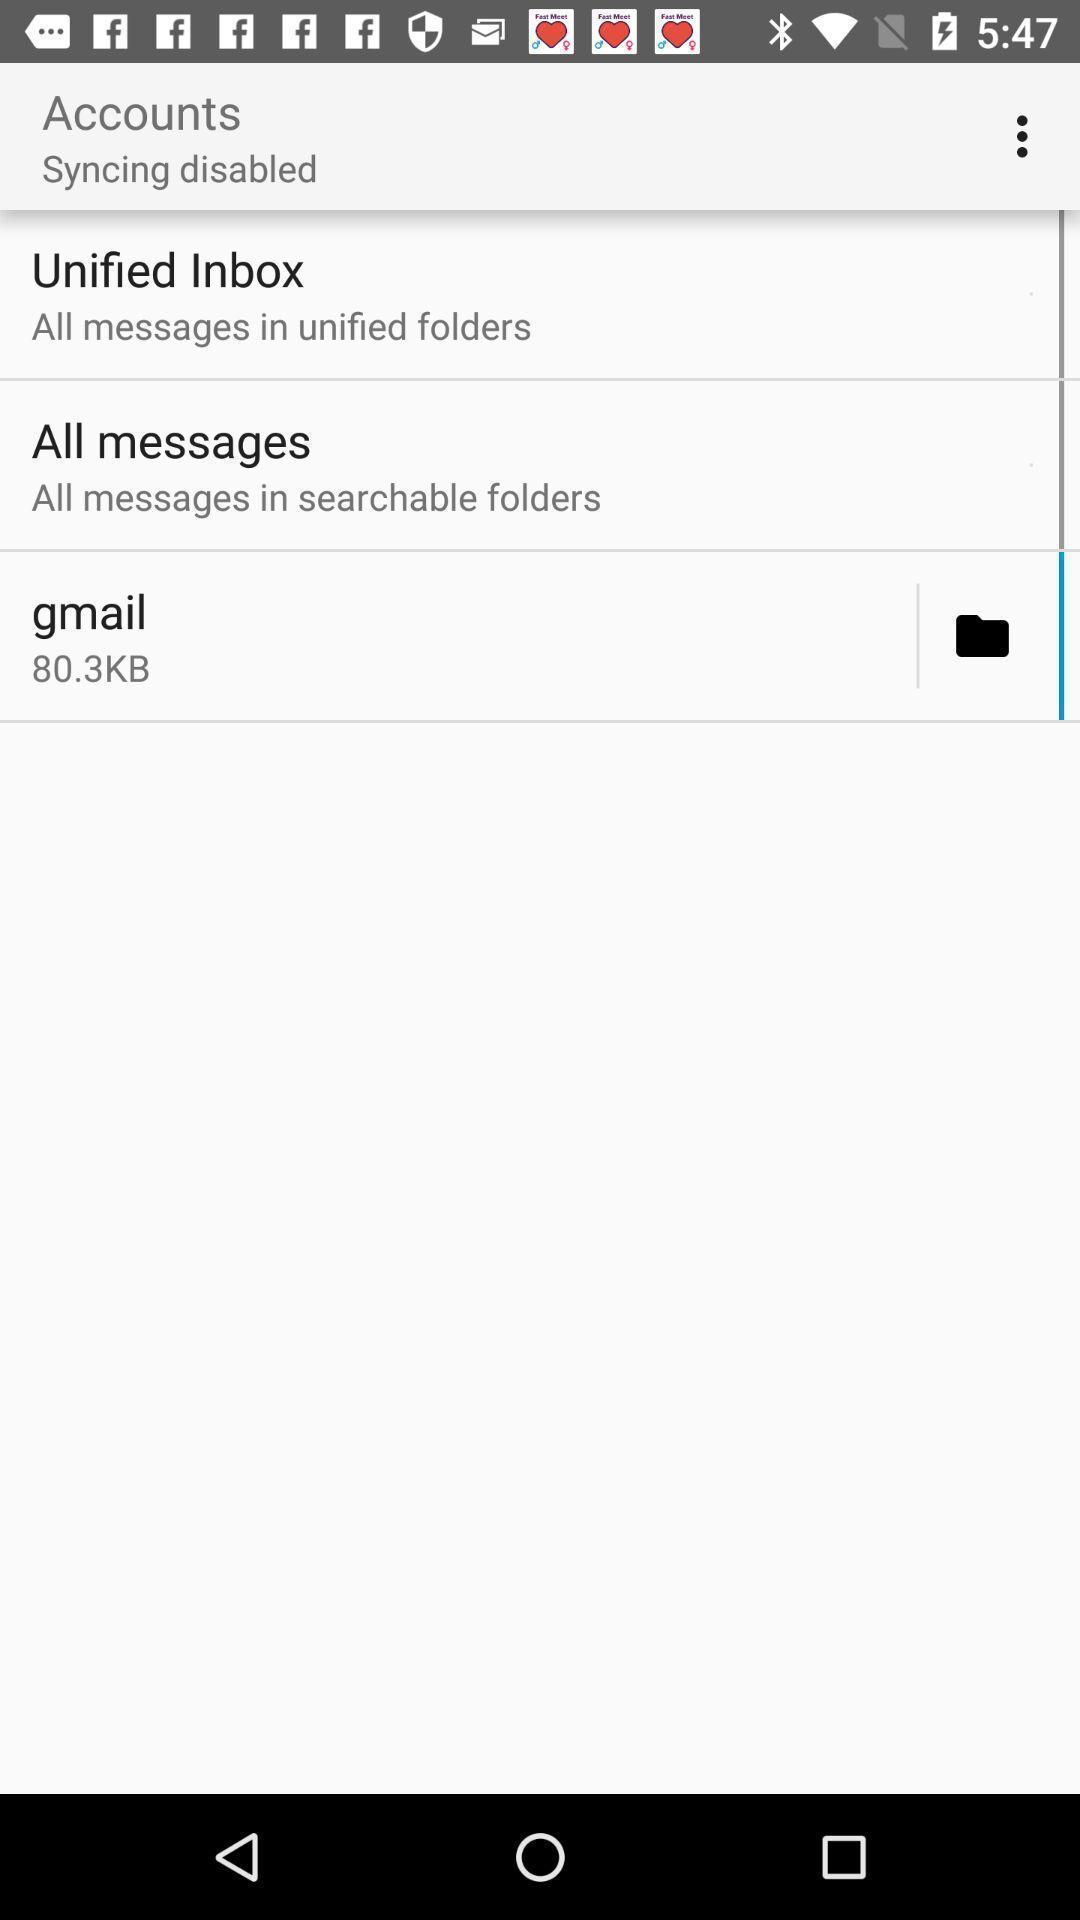Provide a detailed account of this screenshot. Page showing the options to sync accounts. 